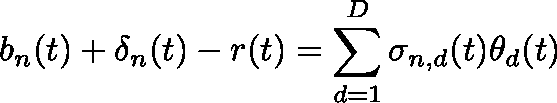<formula> <loc_0><loc_0><loc_500><loc_500>b _ { n } ( t ) + \delta _ { n } ( t ) - r ( t ) = \sum _ { d = 1 } ^ { D } \sigma _ { n , d } ( t ) \theta _ { d } ( t )</formula> 